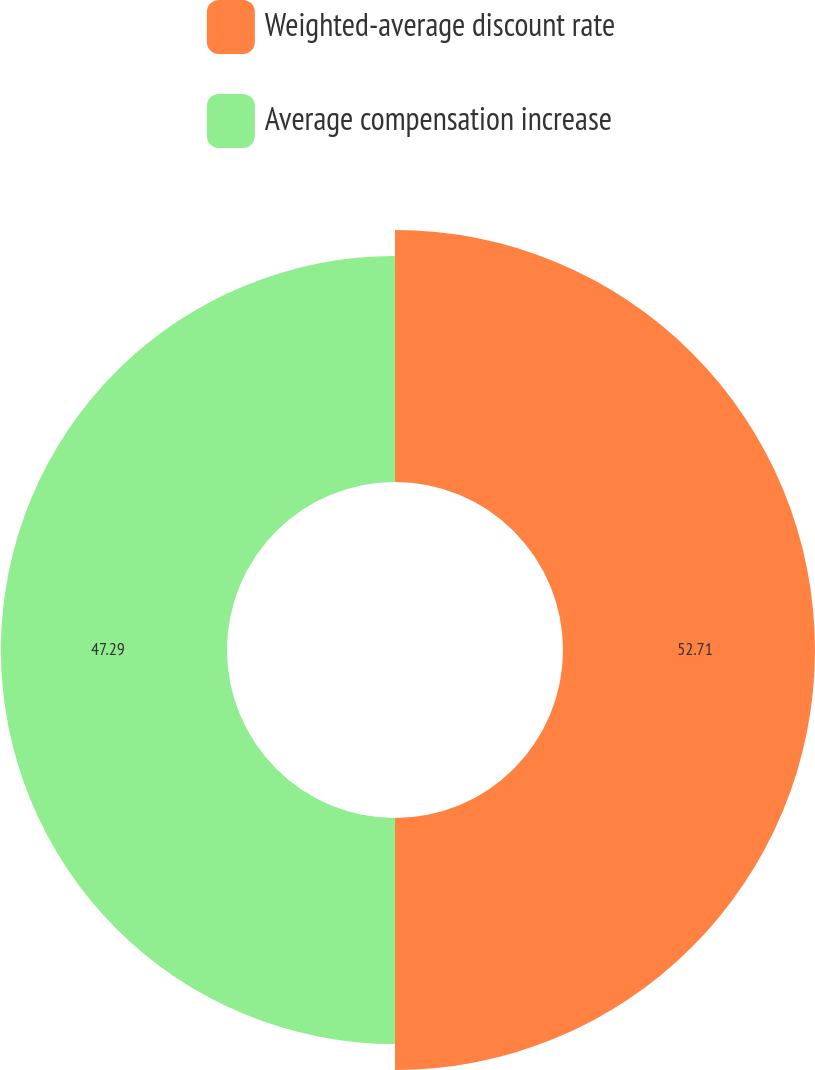Convert chart. <chart><loc_0><loc_0><loc_500><loc_500><pie_chart><fcel>Weighted-average discount rate<fcel>Average compensation increase<nl><fcel>52.71%<fcel>47.29%<nl></chart> 